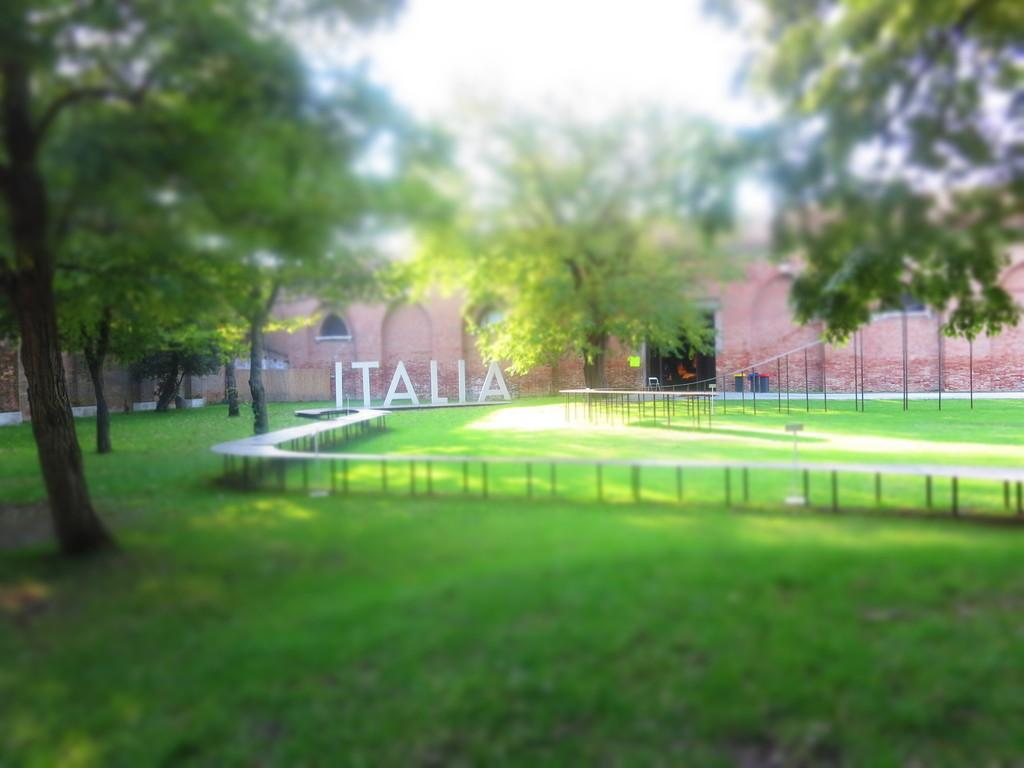What can be seen in the background of the image? There is a wall in the background of the image. What else is present in the image besides the wall? There is some text and grass at the bottom of the image. Are there any natural elements in the image? Yes, there are trees in the image. What type of brake is being used by the trees in the image? There is no brake present in the image; it is a natural scene with trees and grass. 